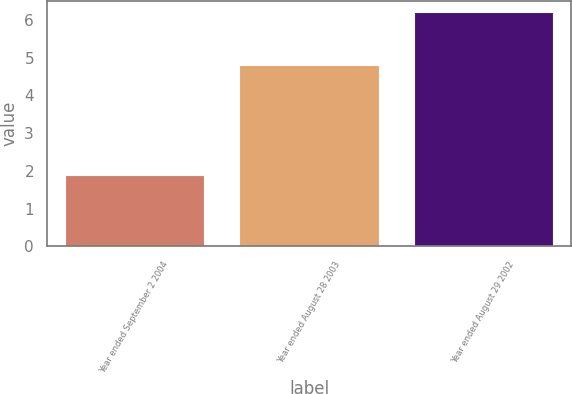Convert chart. <chart><loc_0><loc_0><loc_500><loc_500><bar_chart><fcel>Year ended September 2 2004<fcel>Year ended August 28 2003<fcel>Year ended August 29 2002<nl><fcel>1.9<fcel>4.8<fcel>6.2<nl></chart> 